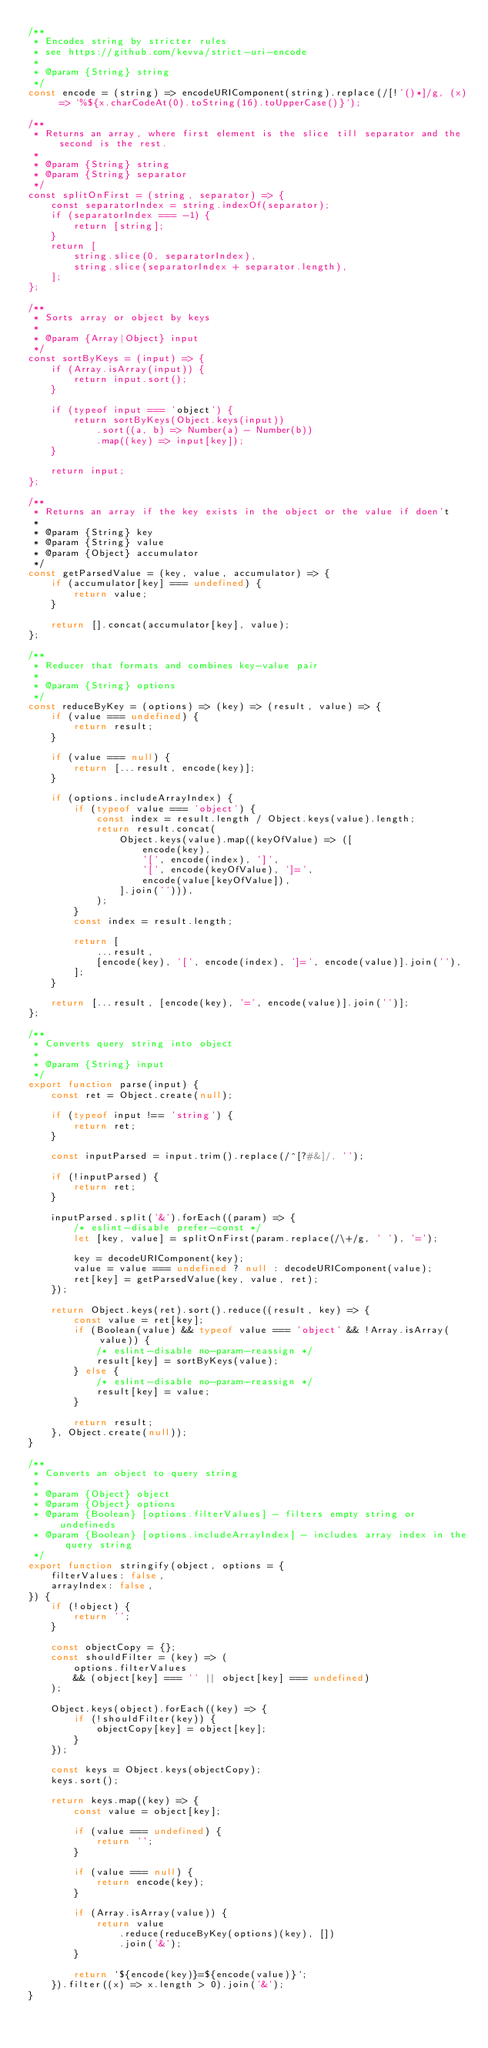Convert code to text. <code><loc_0><loc_0><loc_500><loc_500><_JavaScript_>/**
 * Encodes string by stricter rules
 * see https://github.com/kevva/strict-uri-encode
 *
 * @param {String} string
 */
const encode = (string) => encodeURIComponent(string).replace(/[!'()*]/g, (x) => `%${x.charCodeAt(0).toString(16).toUpperCase()}`);

/**
 * Returns an array, where first element is the slice till separator and the second is the rest.
 *
 * @param {String} string
 * @param {String} separator
 */
const splitOnFirst = (string, separator) => {
    const separatorIndex = string.indexOf(separator);
    if (separatorIndex === -1) {
        return [string];
    }
    return [
        string.slice(0, separatorIndex),
        string.slice(separatorIndex + separator.length),
    ];
};

/**
 * Sorts array or object by keys
 *
 * @param {Array|Object} input
 */
const sortByKeys = (input) => {
    if (Array.isArray(input)) {
        return input.sort();
    }

    if (typeof input === 'object') {
        return sortByKeys(Object.keys(input))
            .sort((a, b) => Number(a) - Number(b))
            .map((key) => input[key]);
    }

    return input;
};

/**
 * Returns an array if the key exists in the object or the value if doen't
 *
 * @param {String} key
 * @param {String} value
 * @param {Object} accumulator
 */
const getParsedValue = (key, value, accumulator) => {
    if (accumulator[key] === undefined) {
        return value;
    }

    return [].concat(accumulator[key], value);
};

/**
 * Reducer that formats and combines key-value pair
 *
 * @param {String} options
 */
const reduceByKey = (options) => (key) => (result, value) => {
    if (value === undefined) {
        return result;
    }

    if (value === null) {
        return [...result, encode(key)];
    }

    if (options.includeArrayIndex) {
        if (typeof value === 'object') {
            const index = result.length / Object.keys(value).length;
            return result.concat(
                Object.keys(value).map((keyOfValue) => ([
                    encode(key),
                    '[', encode(index), ']',
                    '[', encode(keyOfValue), ']=',
                    encode(value[keyOfValue]),
                ].join(''))),
            );
        }
        const index = result.length;

        return [
            ...result,
            [encode(key), '[', encode(index), ']=', encode(value)].join(''),
        ];
    }

    return [...result, [encode(key), '=', encode(value)].join('')];
};

/**
 * Converts query string into object
 *
 * @param {String} input
 */
export function parse(input) {
    const ret = Object.create(null);

    if (typeof input !== 'string') {
        return ret;
    }

    const inputParsed = input.trim().replace(/^[?#&]/, '');

    if (!inputParsed) {
        return ret;
    }

    inputParsed.split('&').forEach((param) => {
        /* eslint-disable prefer-const */
        let [key, value] = splitOnFirst(param.replace(/\+/g, ' '), '=');

        key = decodeURIComponent(key);
        value = value === undefined ? null : decodeURIComponent(value);
        ret[key] = getParsedValue(key, value, ret);
    });

    return Object.keys(ret).sort().reduce((result, key) => {
        const value = ret[key];
        if (Boolean(value) && typeof value === 'object' && !Array.isArray(value)) {
            /* eslint-disable no-param-reassign */
            result[key] = sortByKeys(value);
        } else {
            /* eslint-disable no-param-reassign */
            result[key] = value;
        }

        return result;
    }, Object.create(null));
}

/**
 * Converts an object to query string
 *
 * @param {Object} object
 * @param {Object} options
 * @param {Boolean} [options.filterValues] - filters empty string or undefineds
 * @param {Boolean} [options.includeArrayIndex] - includes array index in the query string
 */
export function stringify(object, options = {
    filterValues: false,
    arrayIndex: false,
}) {
    if (!object) {
        return '';
    }

    const objectCopy = {};
    const shouldFilter = (key) => (
        options.filterValues
        && (object[key] === '' || object[key] === undefined)
    );

    Object.keys(object).forEach((key) => {
        if (!shouldFilter(key)) {
            objectCopy[key] = object[key];
        }
    });

    const keys = Object.keys(objectCopy);
    keys.sort();

    return keys.map((key) => {
        const value = object[key];

        if (value === undefined) {
            return '';
        }

        if (value === null) {
            return encode(key);
        }

        if (Array.isArray(value)) {
            return value
                .reduce(reduceByKey(options)(key), [])
                .join('&');
        }

        return `${encode(key)}=${encode(value)}`;
    }).filter((x) => x.length > 0).join('&');
}
</code> 